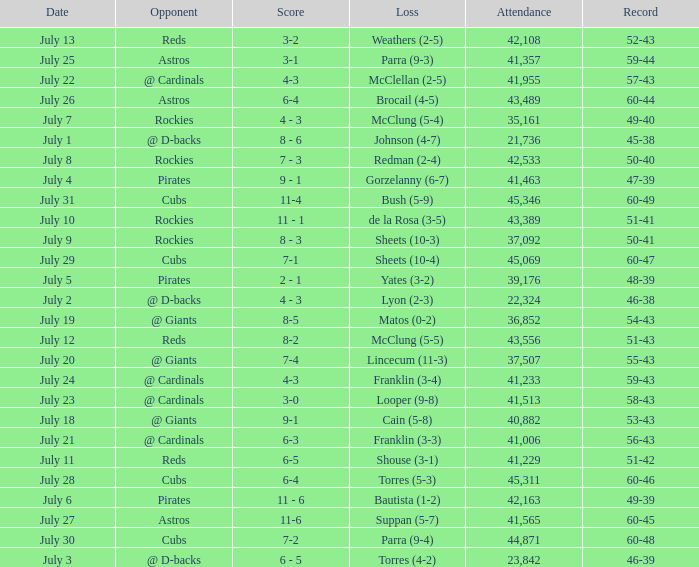What's the attendance of the game where there was a Loss of Yates (3-2)? 39176.0. Could you parse the entire table? {'header': ['Date', 'Opponent', 'Score', 'Loss', 'Attendance', 'Record'], 'rows': [['July 13', 'Reds', '3-2', 'Weathers (2-5)', '42,108', '52-43'], ['July 25', 'Astros', '3-1', 'Parra (9-3)', '41,357', '59-44'], ['July 22', '@ Cardinals', '4-3', 'McClellan (2-5)', '41,955', '57-43'], ['July 26', 'Astros', '6-4', 'Brocail (4-5)', '43,489', '60-44'], ['July 7', 'Rockies', '4 - 3', 'McClung (5-4)', '35,161', '49-40'], ['July 1', '@ D-backs', '8 - 6', 'Johnson (4-7)', '21,736', '45-38'], ['July 8', 'Rockies', '7 - 3', 'Redman (2-4)', '42,533', '50-40'], ['July 4', 'Pirates', '9 - 1', 'Gorzelanny (6-7)', '41,463', '47-39'], ['July 31', 'Cubs', '11-4', 'Bush (5-9)', '45,346', '60-49'], ['July 10', 'Rockies', '11 - 1', 'de la Rosa (3-5)', '43,389', '51-41'], ['July 9', 'Rockies', '8 - 3', 'Sheets (10-3)', '37,092', '50-41'], ['July 29', 'Cubs', '7-1', 'Sheets (10-4)', '45,069', '60-47'], ['July 5', 'Pirates', '2 - 1', 'Yates (3-2)', '39,176', '48-39'], ['July 2', '@ D-backs', '4 - 3', 'Lyon (2-3)', '22,324', '46-38'], ['July 19', '@ Giants', '8-5', 'Matos (0-2)', '36,852', '54-43'], ['July 12', 'Reds', '8-2', 'McClung (5-5)', '43,556', '51-43'], ['July 20', '@ Giants', '7-4', 'Lincecum (11-3)', '37,507', '55-43'], ['July 24', '@ Cardinals', '4-3', 'Franklin (3-4)', '41,233', '59-43'], ['July 23', '@ Cardinals', '3-0', 'Looper (9-8)', '41,513', '58-43'], ['July 18', '@ Giants', '9-1', 'Cain (5-8)', '40,882', '53-43'], ['July 21', '@ Cardinals', '6-3', 'Franklin (3-3)', '41,006', '56-43'], ['July 11', 'Reds', '6-5', 'Shouse (3-1)', '41,229', '51-42'], ['July 28', 'Cubs', '6-4', 'Torres (5-3)', '45,311', '60-46'], ['July 6', 'Pirates', '11 - 6', 'Bautista (1-2)', '42,163', '49-39'], ['July 27', 'Astros', '11-6', 'Suppan (5-7)', '41,565', '60-45'], ['July 30', 'Cubs', '7-2', 'Parra (9-4)', '44,871', '60-48'], ['July 3', '@ D-backs', '6 - 5', 'Torres (4-2)', '23,842', '46-39']]} 